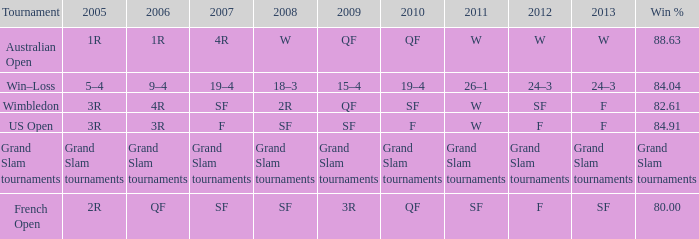What in 2007 has a 2008 of sf, and a 2010 of f? F. 